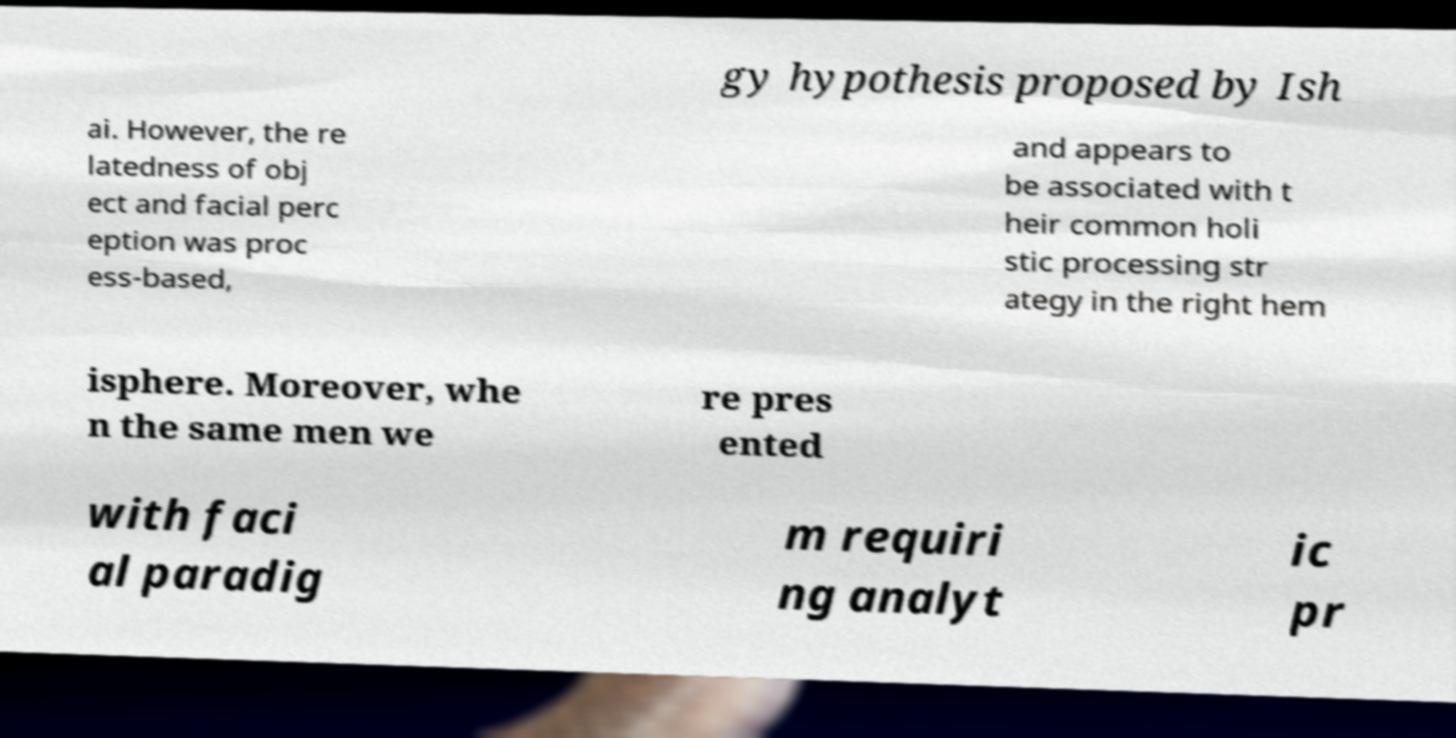For documentation purposes, I need the text within this image transcribed. Could you provide that? gy hypothesis proposed by Ish ai. However, the re latedness of obj ect and facial perc eption was proc ess-based, and appears to be associated with t heir common holi stic processing str ategy in the right hem isphere. Moreover, whe n the same men we re pres ented with faci al paradig m requiri ng analyt ic pr 